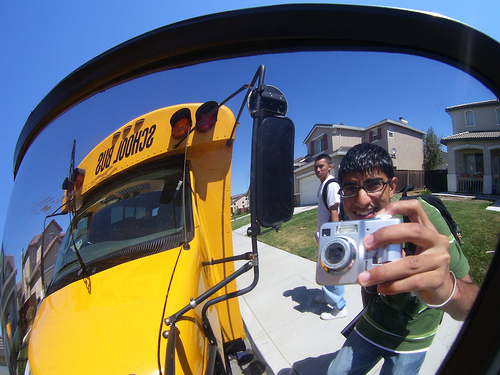Please provide the bounding box coordinate of the region this sentence describes: the boy is smiling. The bounding box for the region described by 'the boy is smiling' is [0.66, 0.41, 0.8, 0.57]. 